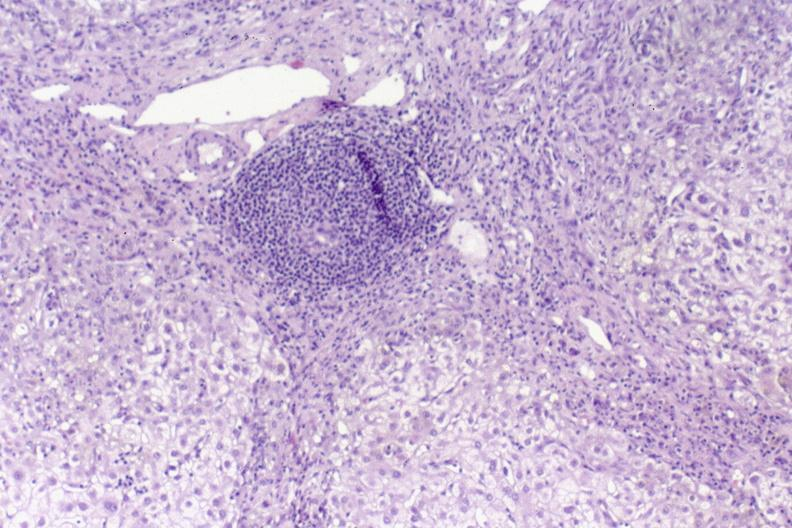s rocky mountain present?
Answer the question using a single word or phrase. No 